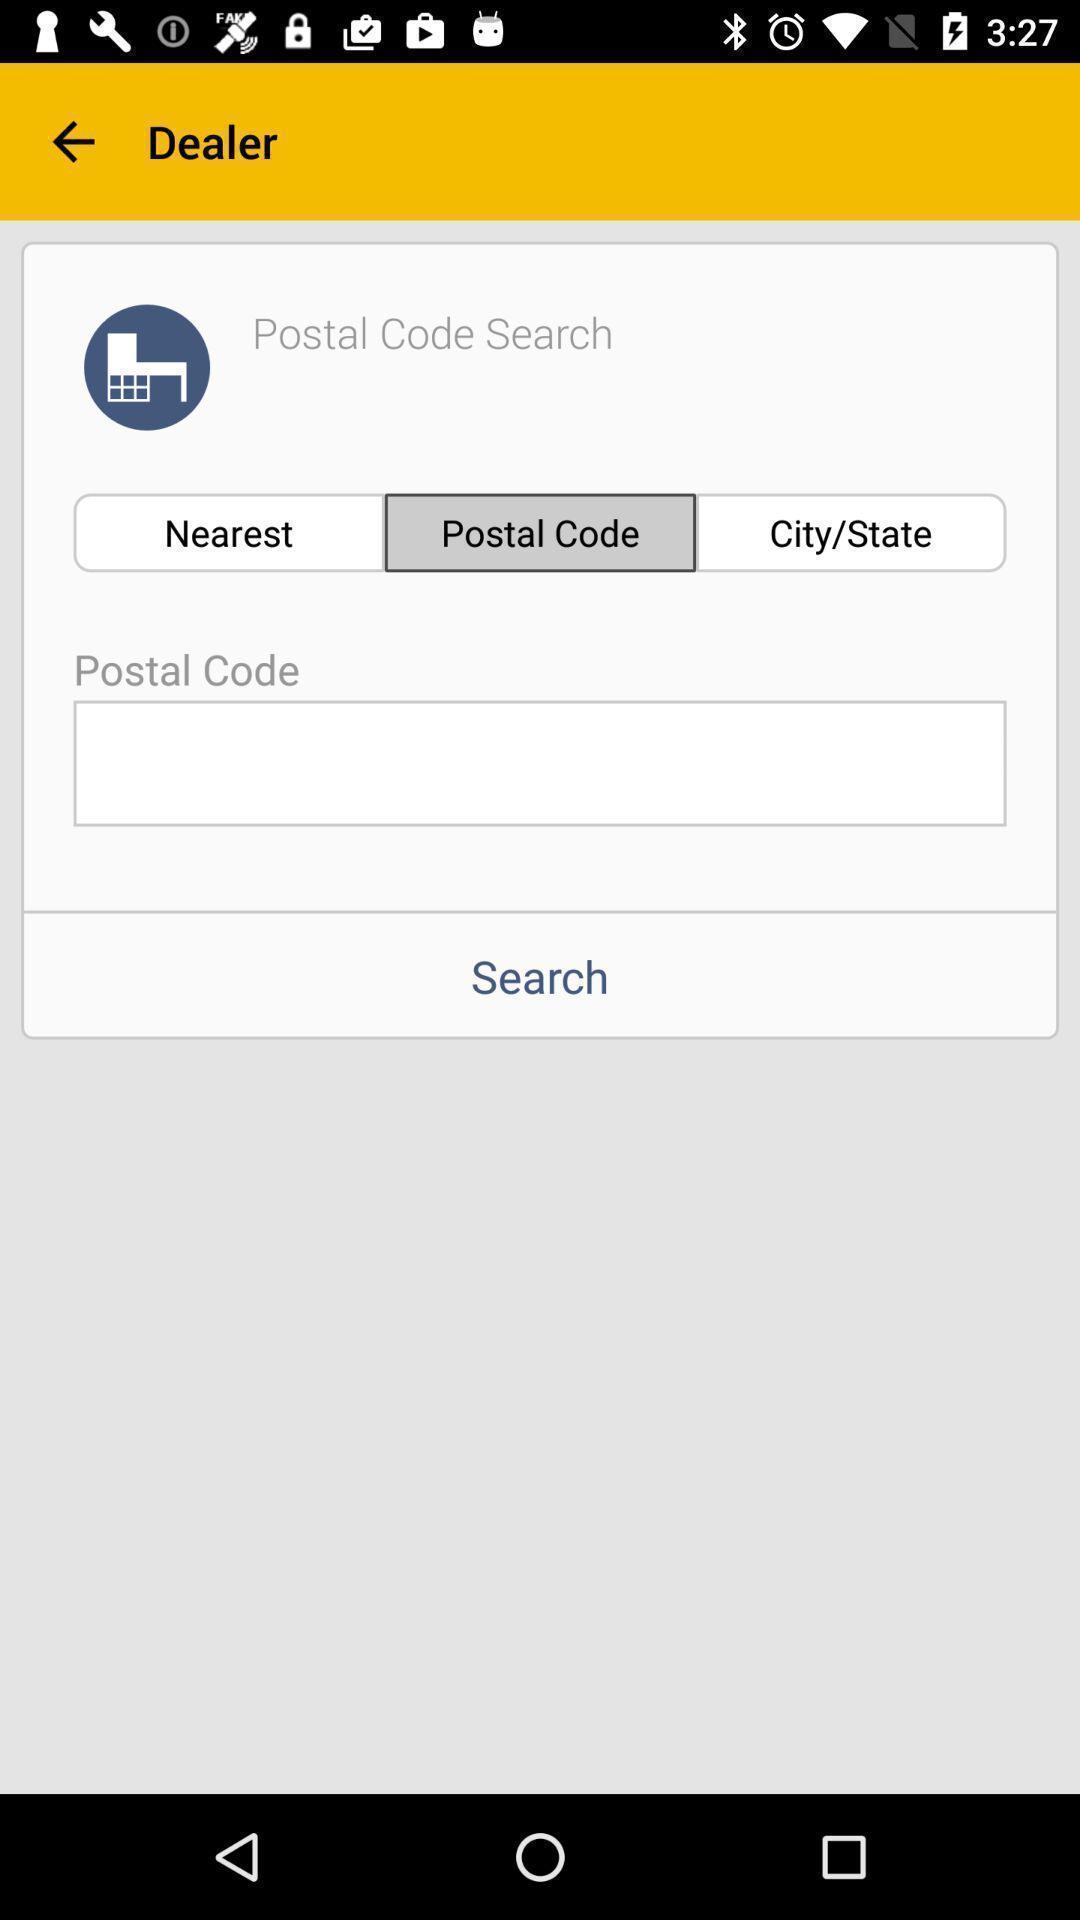Explain the elements present in this screenshot. Search option page of a vehicle maintenance app. 